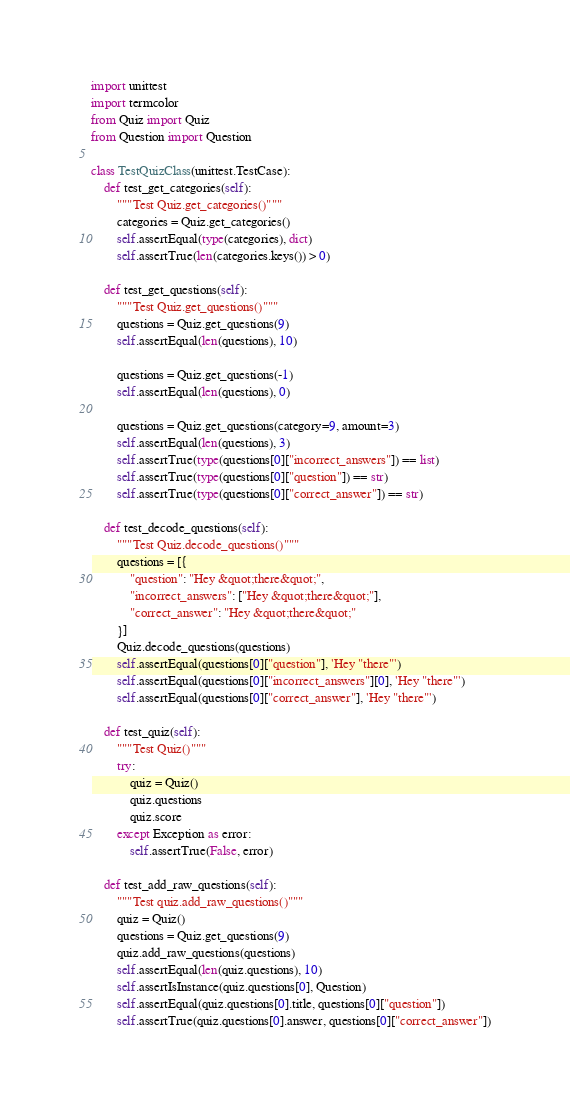Convert code to text. <code><loc_0><loc_0><loc_500><loc_500><_Python_>import unittest
import termcolor
from Quiz import Quiz
from Question import Question

class TestQuizClass(unittest.TestCase):
    def test_get_categories(self):
        """Test Quiz.get_categories()"""
        categories = Quiz.get_categories()
        self.assertEqual(type(categories), dict)
        self.assertTrue(len(categories.keys()) > 0)
    
    def test_get_questions(self):
        """Test Quiz.get_questions()"""
        questions = Quiz.get_questions(9)
        self.assertEqual(len(questions), 10)

        questions = Quiz.get_questions(-1)
        self.assertEqual(len(questions), 0)

        questions = Quiz.get_questions(category=9, amount=3)
        self.assertEqual(len(questions), 3)
        self.assertTrue(type(questions[0]["incorrect_answers"]) == list)
        self.assertTrue(type(questions[0]["question"]) == str)
        self.assertTrue(type(questions[0]["correct_answer"]) == str)

    def test_decode_questions(self):
        """Test Quiz.decode_questions()"""
        questions = [{
            "question": "Hey &quot;there&quot;",
            "incorrect_answers": ["Hey &quot;there&quot;"],
            "correct_answer": "Hey &quot;there&quot;"
        }]
        Quiz.decode_questions(questions)
        self.assertEqual(questions[0]["question"], 'Hey "there"')
        self.assertEqual(questions[0]["incorrect_answers"][0], 'Hey "there"')
        self.assertEqual(questions[0]["correct_answer"], 'Hey "there"')
    
    def test_quiz(self):
        """Test Quiz()"""
        try:
            quiz = Quiz()
            quiz.questions
            quiz.score
        except Exception as error:
            self.assertTrue(False, error)

    def test_add_raw_questions(self):
        """Test quiz.add_raw_questions()"""
        quiz = Quiz()
        questions = Quiz.get_questions(9)
        quiz.add_raw_questions(questions)
        self.assertEqual(len(quiz.questions), 10)
        self.assertIsInstance(quiz.questions[0], Question)
        self.assertEqual(quiz.questions[0].title, questions[0]["question"])
        self.assertTrue(quiz.questions[0].answer, questions[0]["correct_answer"])</code> 